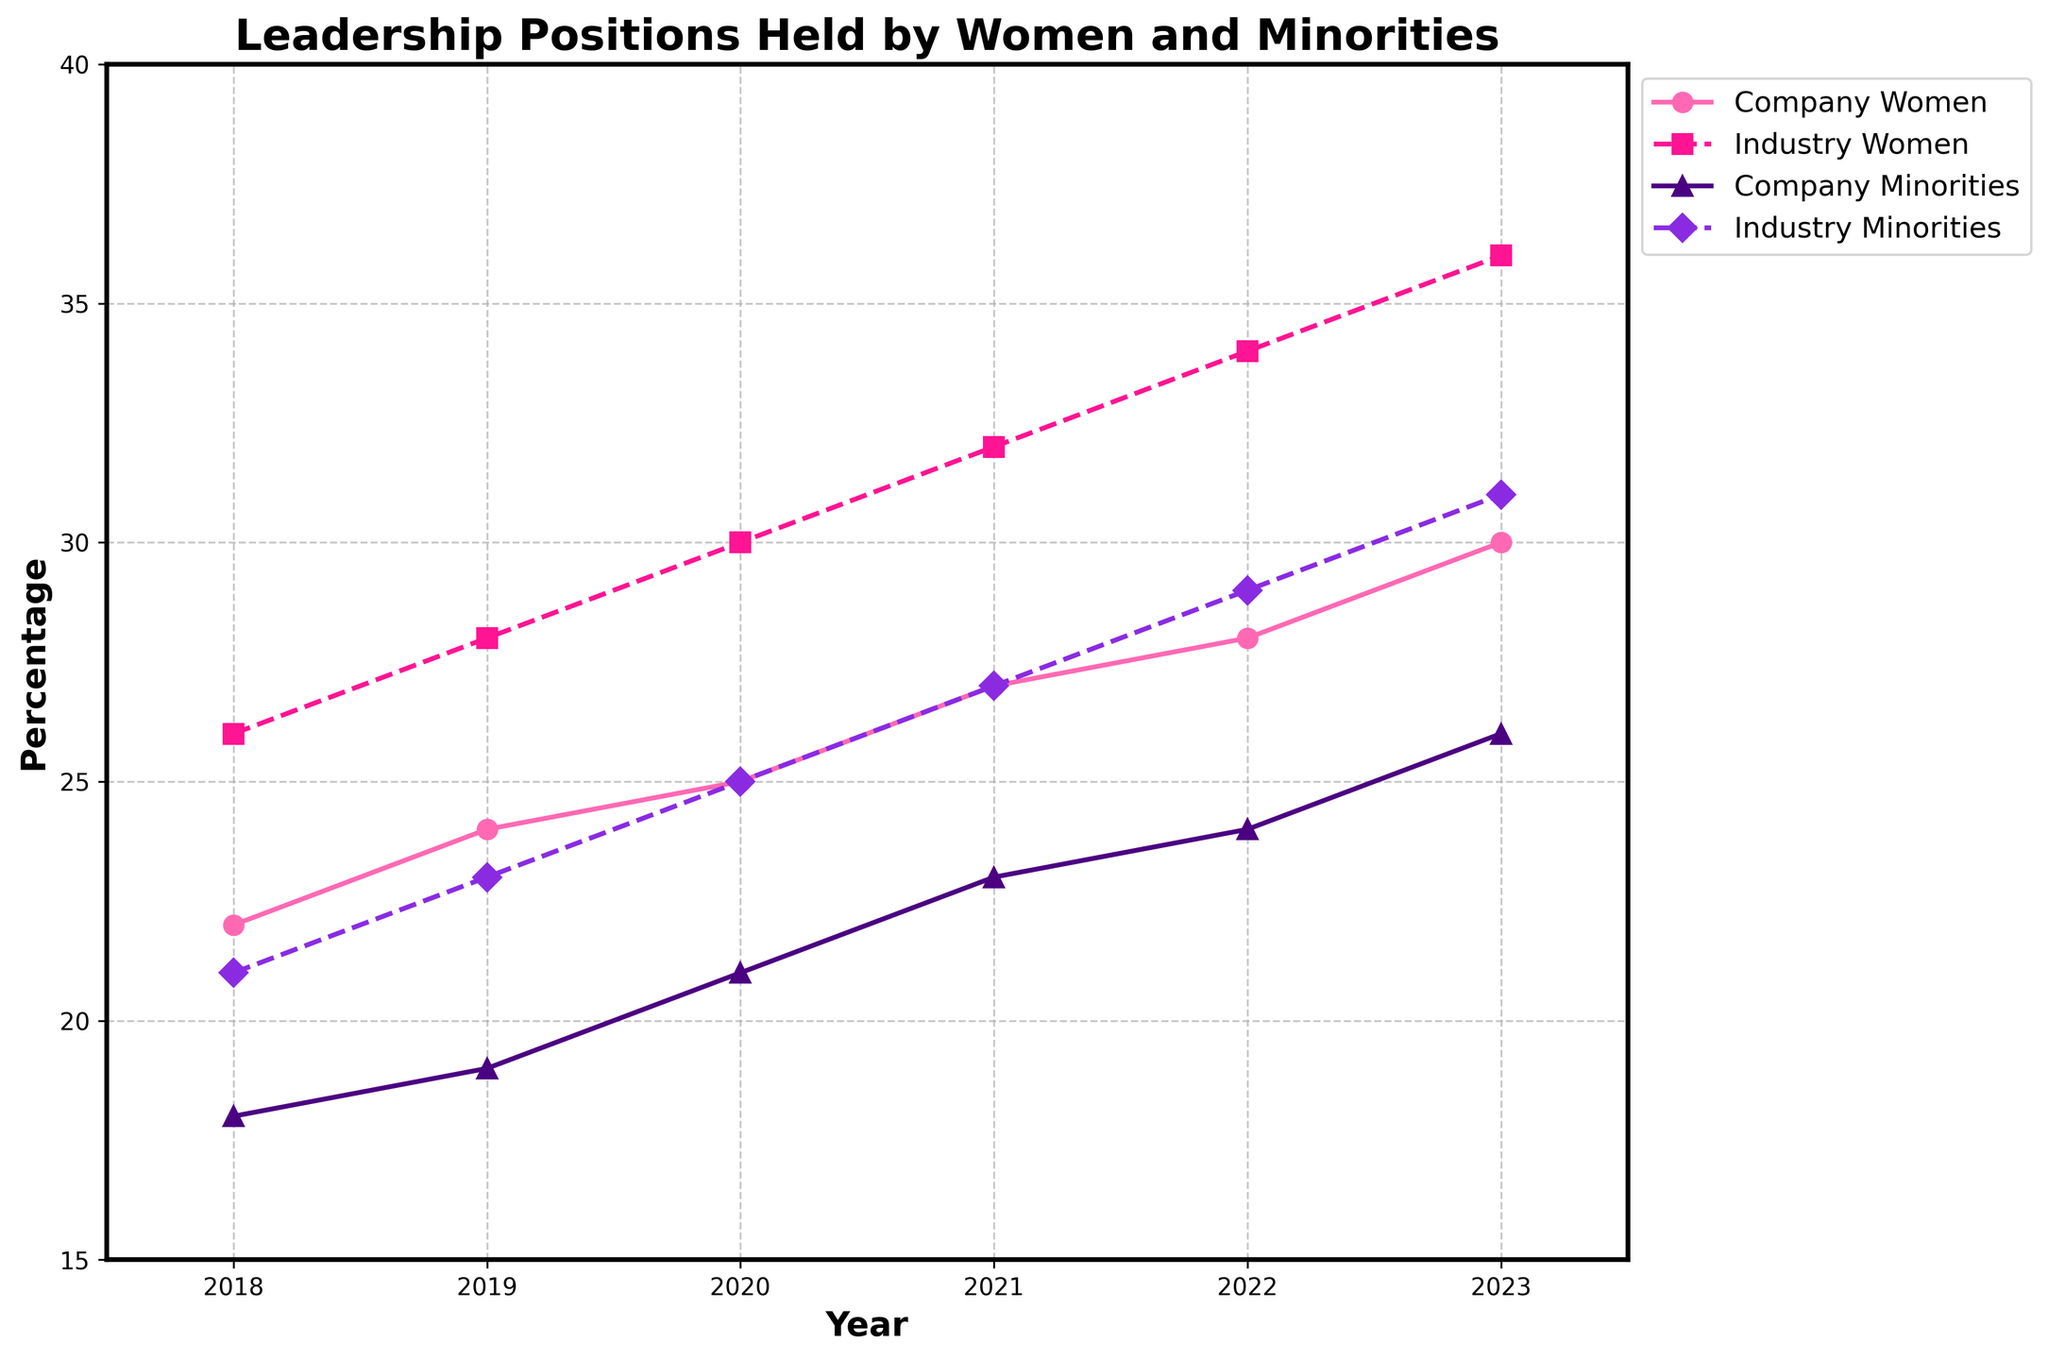How does the percentage of leadership positions held by women in the company compare to the industry average in 2022? In 2022, the company had 28% of leadership positions held by women, while the industry average was 34%. To compare, subtract the company's percentage from the industry's: 34% - 28% = 6%.
Answer: 6% lower Between 2018 and 2023, in which year did the company see the largest increase in the percentage of leadership positions held by minorities? Calculate the increase for each year: 2019 (19% - 18% = 1%), 2020 (21% - 19% = 2%), 2021 (23% - 21% = 2%), 2022 (24% - 23% = 1%), 2023 (26% - 24% = 2%). The largest increase was in 2020, 2021, and 2023 with an increase of 2%.
Answer: 2020, 2021, 2023 What’s the difference in the percentage of leadership positions held by minorities between the company and industry in 2020? In 2020, the company had 21% while the industry had 25%. The difference is calculated as: 25% - 21% = 4%.
Answer: 4% How did the percentage of leadership positions held by women in the company change from 2018 to 2023? In 2018, the percentage was 22%, and in 2023, it was 30%. The change can be calculated as: 30% - 22% = 8%.
Answer: 8% increase In 2021, did the company have a higher percentage of leadership positions held by women or minorities? In 2021, the company had 27% of leadership positions held by women and 23% by minorities. Comparing these values, 27% is greater than 23%.
Answer: Women Which group had the least representation in the company's leadership in 2018? In 2018, women had 22% and minorities had 18% in leadership positions. Comparing these values, 18% (minorities) is smaller than 22% (women).
Answer: Minorities How does the trend for company's leadership positions held by women compare visually to that of industry averages from 2018 to 2023? Both trends are upward; however, the company's trend has a consistent but smaller increase compared to the sharper and more substantial increase in the industry average.
Answer: Smaller increase What is the average percentage of leadership positions held by women in the company over the years 2018-2023? Sum the percentages and divide by the number of years: (22% + 24% + 25% + 27% + 28% + 30%) / 6 = 156% / 6 = 26%.
Answer: 26% What is the combined percentage change for leadership positions held by minorities in the company and industry from 2018 to 2023? Calculate the change for the company: 26% - 18% = 8%, and for the industry: 31% - 21% = 10%. Combined change is 8% + 10% = 18%.
Answer: 18% 